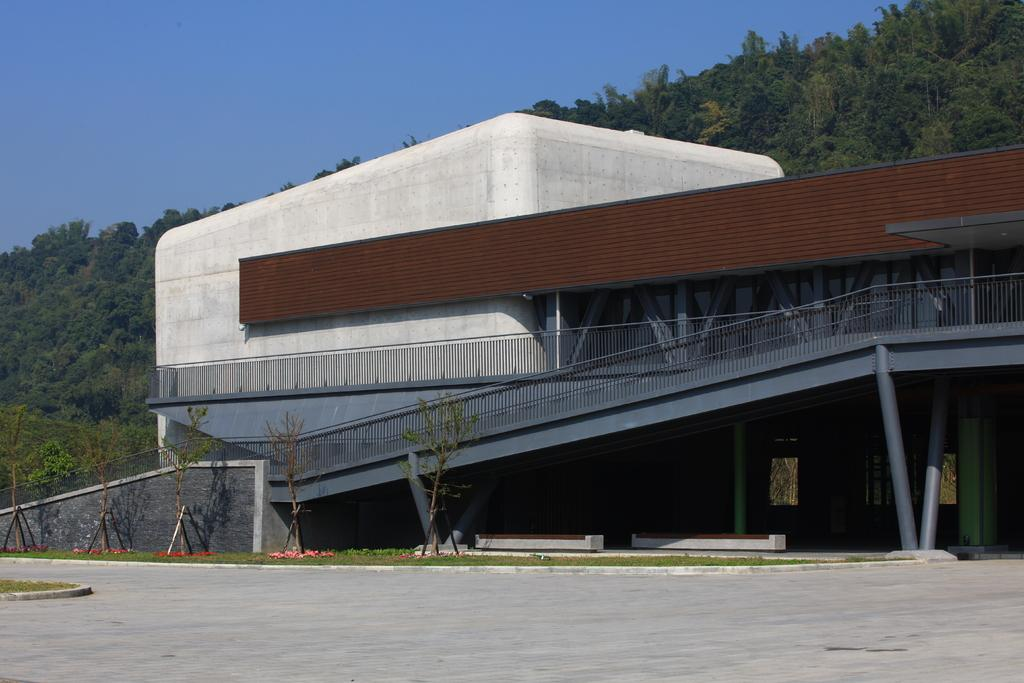What is located at the bottom of the image? There is a road at the bottom of the image. What structure can be seen in the image? There is a building in the image. What type of vegetation is visible in the background of the image? There are trees in the background of the image. What part of the natural environment is visible in the image? The sky is visible in the background of the image. Why did the bag suddenly drop from the sky in the image? There is no bag or any object falling from the sky in the image. 